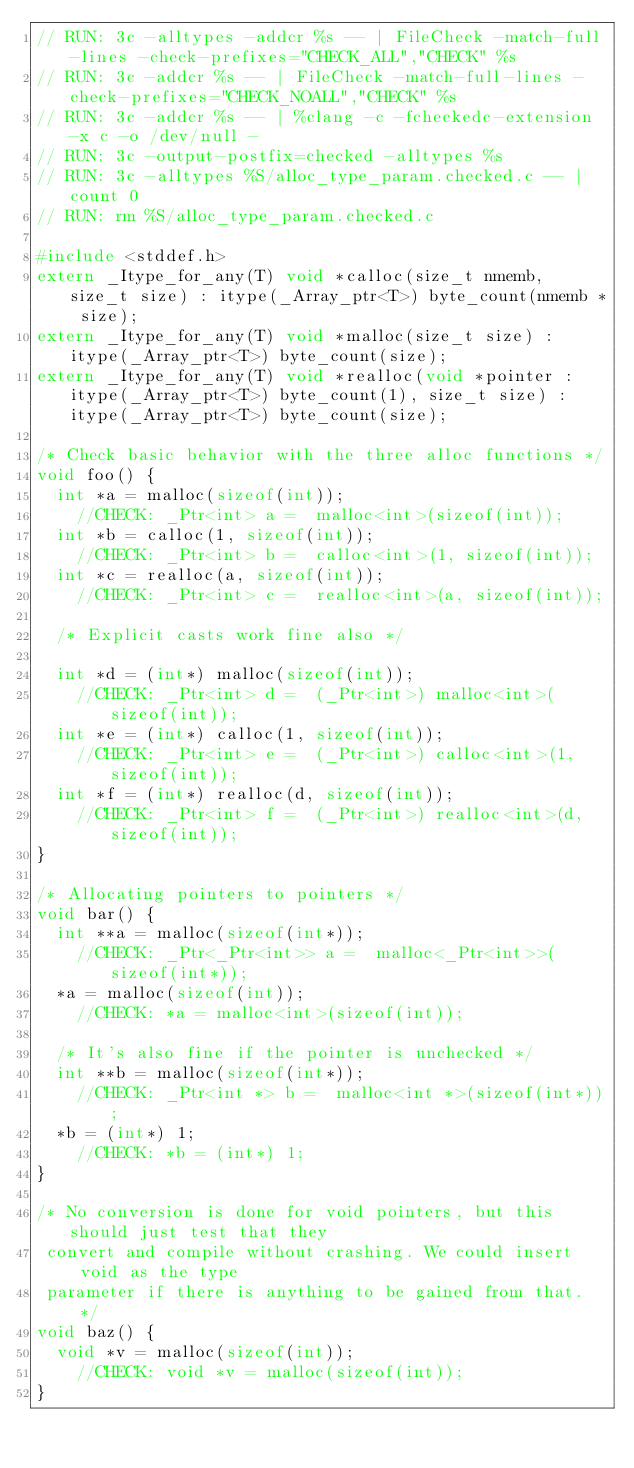<code> <loc_0><loc_0><loc_500><loc_500><_C_>// RUN: 3c -alltypes -addcr %s -- | FileCheck -match-full-lines -check-prefixes="CHECK_ALL","CHECK" %s
// RUN: 3c -addcr %s -- | FileCheck -match-full-lines -check-prefixes="CHECK_NOALL","CHECK" %s
// RUN: 3c -addcr %s -- | %clang -c -fcheckedc-extension -x c -o /dev/null -
// RUN: 3c -output-postfix=checked -alltypes %s
// RUN: 3c -alltypes %S/alloc_type_param.checked.c -- | count 0
// RUN: rm %S/alloc_type_param.checked.c

#include <stddef.h>
extern _Itype_for_any(T) void *calloc(size_t nmemb, size_t size) : itype(_Array_ptr<T>) byte_count(nmemb * size);
extern _Itype_for_any(T) void *malloc(size_t size) : itype(_Array_ptr<T>) byte_count(size);
extern _Itype_for_any(T) void *realloc(void *pointer : itype(_Array_ptr<T>) byte_count(1), size_t size) : itype(_Array_ptr<T>) byte_count(size);

/* Check basic behavior with the three alloc functions */
void foo() {
  int *a = malloc(sizeof(int));
	//CHECK: _Ptr<int> a =  malloc<int>(sizeof(int));
  int *b = calloc(1, sizeof(int));
	//CHECK: _Ptr<int> b =  calloc<int>(1, sizeof(int));
  int *c = realloc(a, sizeof(int));
	//CHECK: _Ptr<int> c =  realloc<int>(a, sizeof(int));

  /* Explicit casts work fine also */

  int *d = (int*) malloc(sizeof(int));
	//CHECK: _Ptr<int> d =  (_Ptr<int>) malloc<int>(sizeof(int));
  int *e = (int*) calloc(1, sizeof(int));
	//CHECK: _Ptr<int> e =  (_Ptr<int>) calloc<int>(1, sizeof(int));
  int *f = (int*) realloc(d, sizeof(int));
	//CHECK: _Ptr<int> f =  (_Ptr<int>) realloc<int>(d, sizeof(int));
}

/* Allocating pointers to pointers */
void bar() {
  int **a = malloc(sizeof(int*));
	//CHECK: _Ptr<_Ptr<int>> a =  malloc<_Ptr<int>>(sizeof(int*));
  *a = malloc(sizeof(int));
	//CHECK: *a = malloc<int>(sizeof(int));

  /* It's also fine if the pointer is unchecked */
  int **b = malloc(sizeof(int*));
	//CHECK: _Ptr<int *> b =  malloc<int *>(sizeof(int*));
  *b = (int*) 1;
	//CHECK: *b = (int*) 1;
}

/* No conversion is done for void pointers, but this should just test that they
 convert and compile without crashing. We could insert void as the type
 parameter if there is anything to be gained from that. */
void baz() {
  void *v = malloc(sizeof(int));
	//CHECK: void *v = malloc(sizeof(int));
}
</code> 